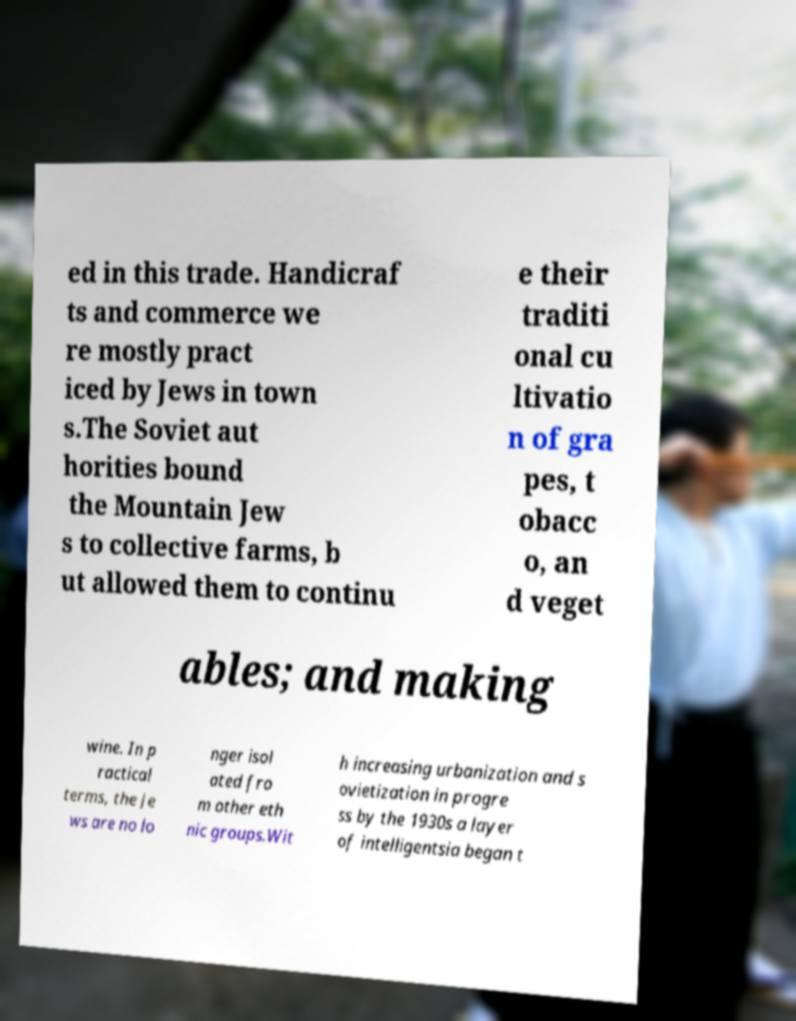I need the written content from this picture converted into text. Can you do that? ed in this trade. Handicraf ts and commerce we re mostly pract iced by Jews in town s.The Soviet aut horities bound the Mountain Jew s to collective farms, b ut allowed them to continu e their traditi onal cu ltivatio n of gra pes, t obacc o, an d veget ables; and making wine. In p ractical terms, the Je ws are no lo nger isol ated fro m other eth nic groups.Wit h increasing urbanization and s ovietization in progre ss by the 1930s a layer of intelligentsia began t 